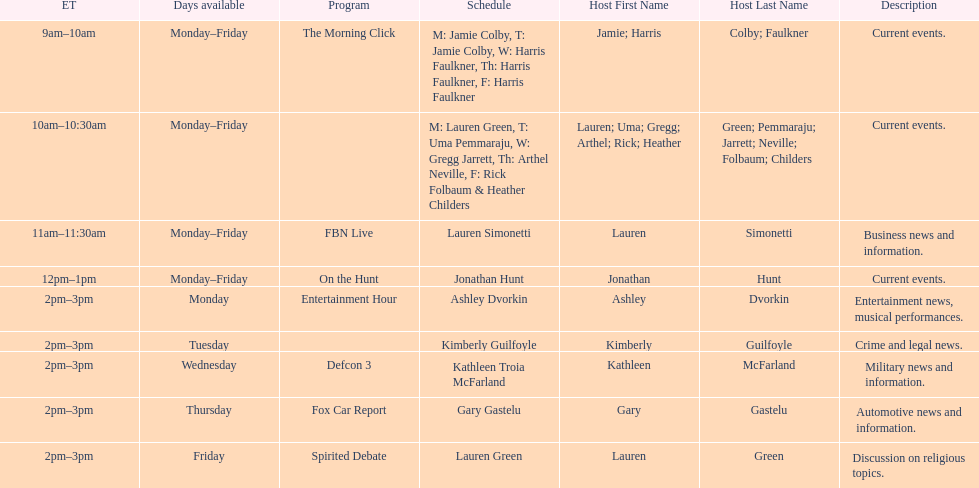Tell me who has her show on fridays at 2. Lauren Green. 